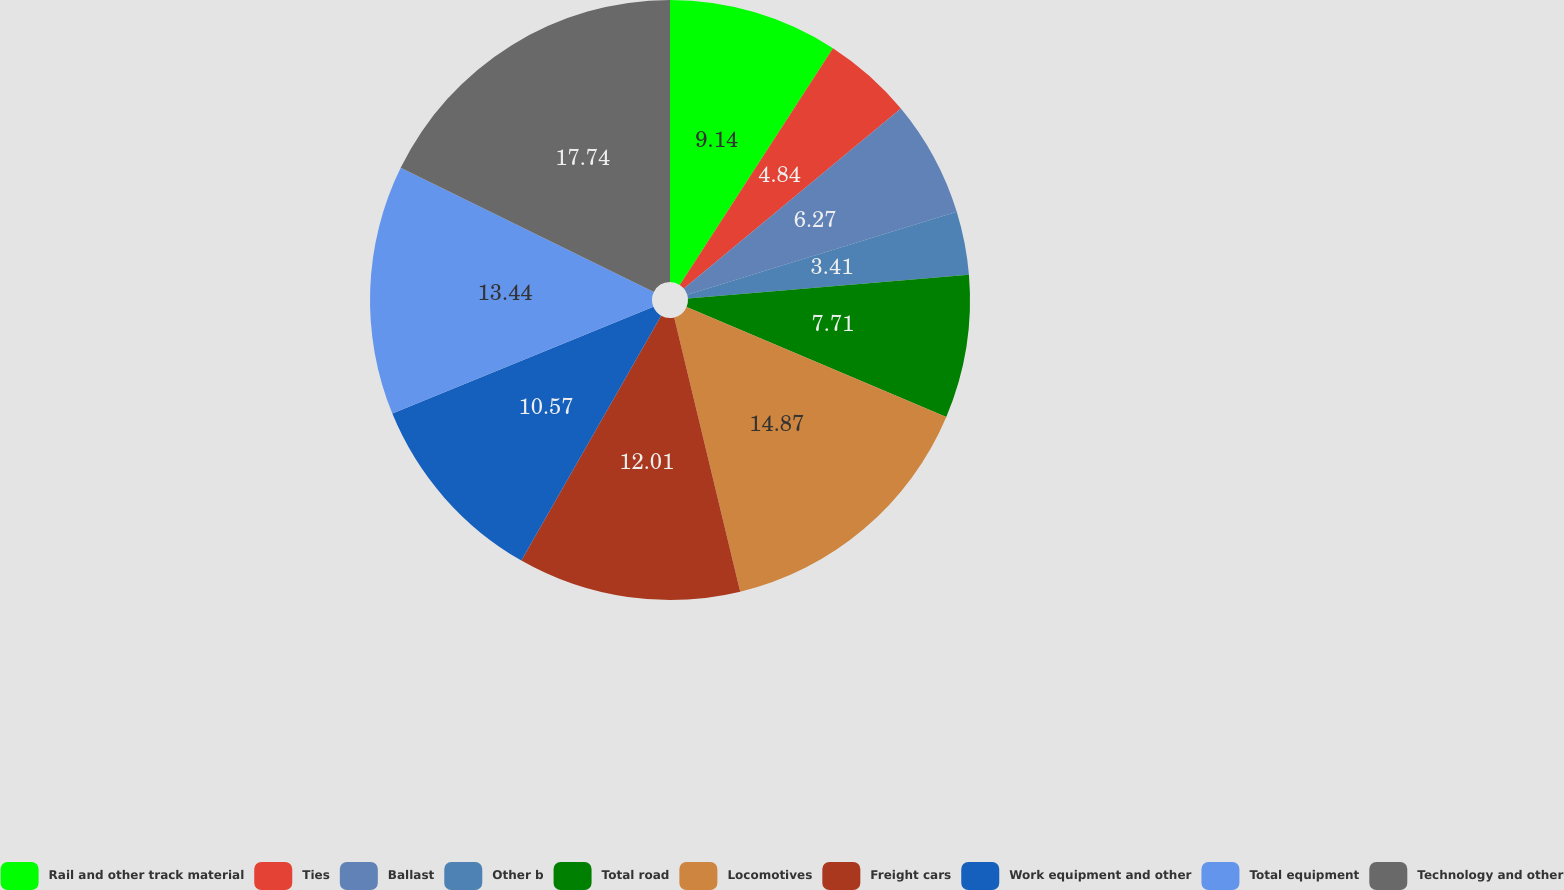Convert chart to OTSL. <chart><loc_0><loc_0><loc_500><loc_500><pie_chart><fcel>Rail and other track material<fcel>Ties<fcel>Ballast<fcel>Other b<fcel>Total road<fcel>Locomotives<fcel>Freight cars<fcel>Work equipment and other<fcel>Total equipment<fcel>Technology and other<nl><fcel>9.14%<fcel>4.84%<fcel>6.27%<fcel>3.41%<fcel>7.71%<fcel>14.87%<fcel>12.01%<fcel>10.57%<fcel>13.44%<fcel>17.74%<nl></chart> 